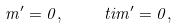Convert formula to latex. <formula><loc_0><loc_0><loc_500><loc_500>m ^ { \prime } = 0 , \quad \ t i { m } ^ { \prime } = 0 ,</formula> 